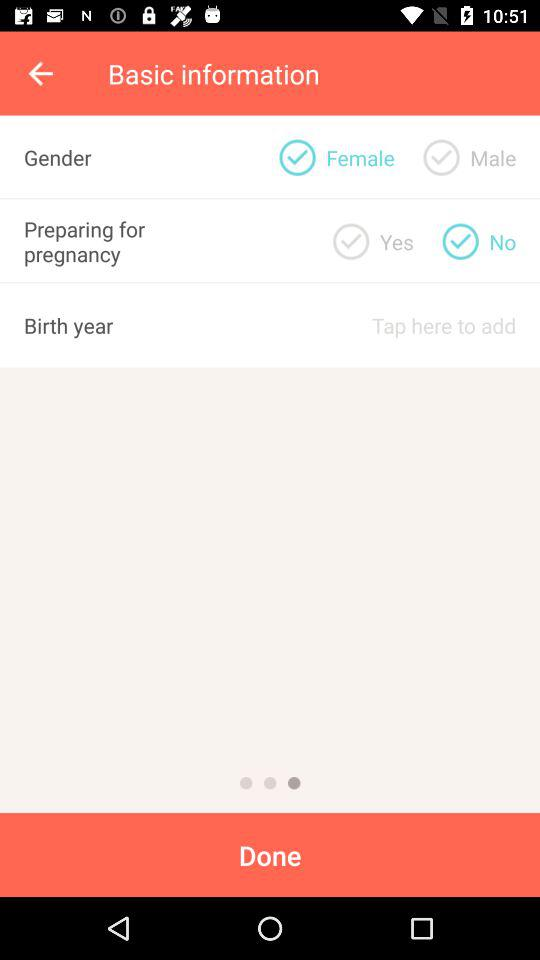What is the gender of the user? The gender of the user is "Female". 